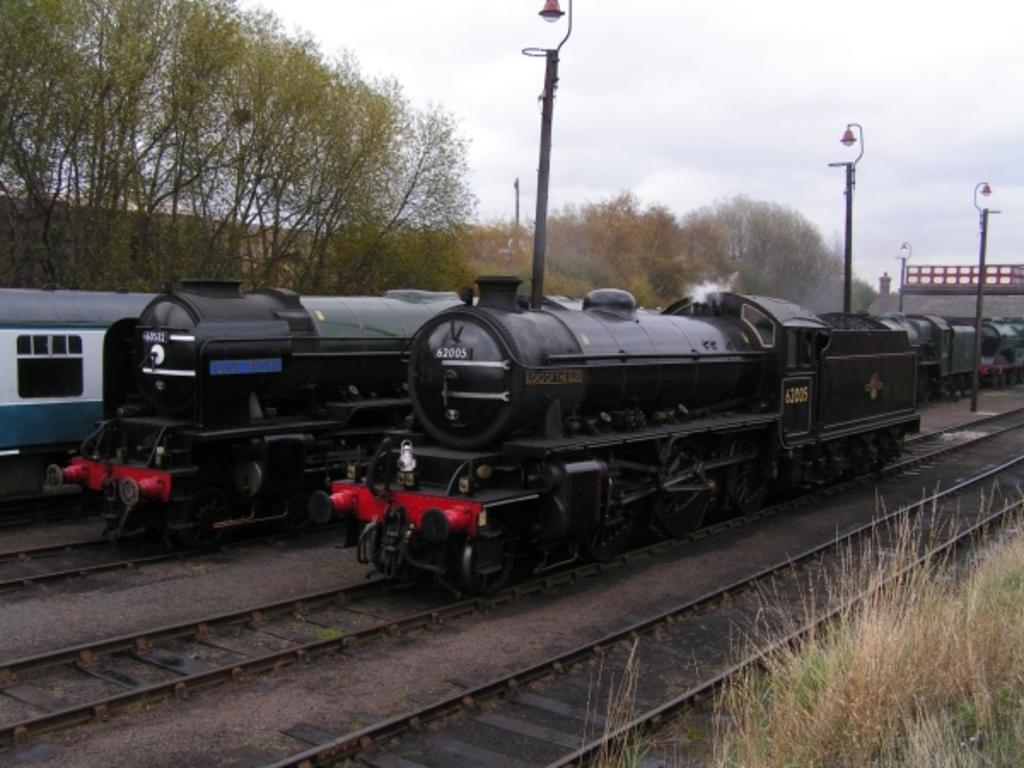What type of vehicles can be seen in the image? There are trains in the image. Where are the trains located? The trains are on railway tracks. What can be seen in the background of the image? Trees, grass, railway tracks, the sky, street lights, and other objects are visible in the background of the image. What type of jelly is being cooked on the channel in the image? There is no jelly or cooking activity present in the image. The image features trains on railway tracks with various background elements. 